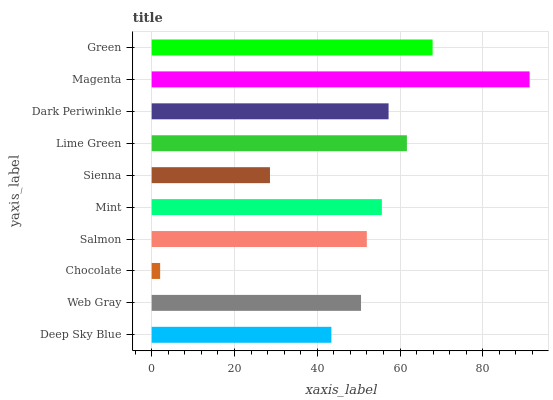Is Chocolate the minimum?
Answer yes or no. Yes. Is Magenta the maximum?
Answer yes or no. Yes. Is Web Gray the minimum?
Answer yes or no. No. Is Web Gray the maximum?
Answer yes or no. No. Is Web Gray greater than Deep Sky Blue?
Answer yes or no. Yes. Is Deep Sky Blue less than Web Gray?
Answer yes or no. Yes. Is Deep Sky Blue greater than Web Gray?
Answer yes or no. No. Is Web Gray less than Deep Sky Blue?
Answer yes or no. No. Is Mint the high median?
Answer yes or no. Yes. Is Salmon the low median?
Answer yes or no. Yes. Is Green the high median?
Answer yes or no. No. Is Dark Periwinkle the low median?
Answer yes or no. No. 